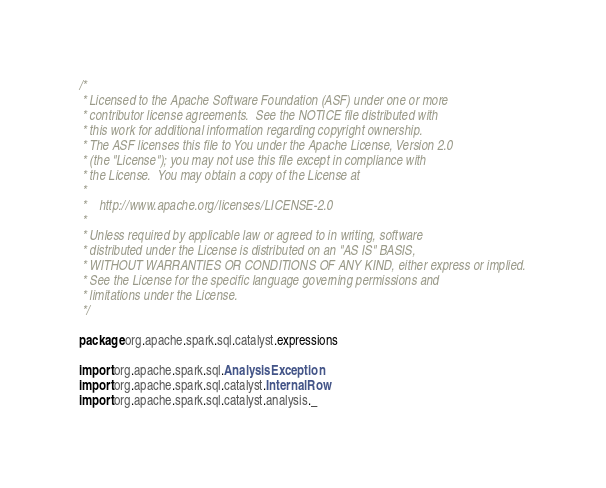Convert code to text. <code><loc_0><loc_0><loc_500><loc_500><_Scala_>/*
 * Licensed to the Apache Software Foundation (ASF) under one or more
 * contributor license agreements.  See the NOTICE file distributed with
 * this work for additional information regarding copyright ownership.
 * The ASF licenses this file to You under the Apache License, Version 2.0
 * (the "License"); you may not use this file except in compliance with
 * the License.  You may obtain a copy of the License at
 *
 *    http://www.apache.org/licenses/LICENSE-2.0
 *
 * Unless required by applicable law or agreed to in writing, software
 * distributed under the License is distributed on an "AS IS" BASIS,
 * WITHOUT WARRANTIES OR CONDITIONS OF ANY KIND, either express or implied.
 * See the License for the specific language governing permissions and
 * limitations under the License.
 */

package org.apache.spark.sql.catalyst.expressions

import org.apache.spark.sql.AnalysisException
import org.apache.spark.sql.catalyst.InternalRow
import org.apache.spark.sql.catalyst.analysis._</code> 